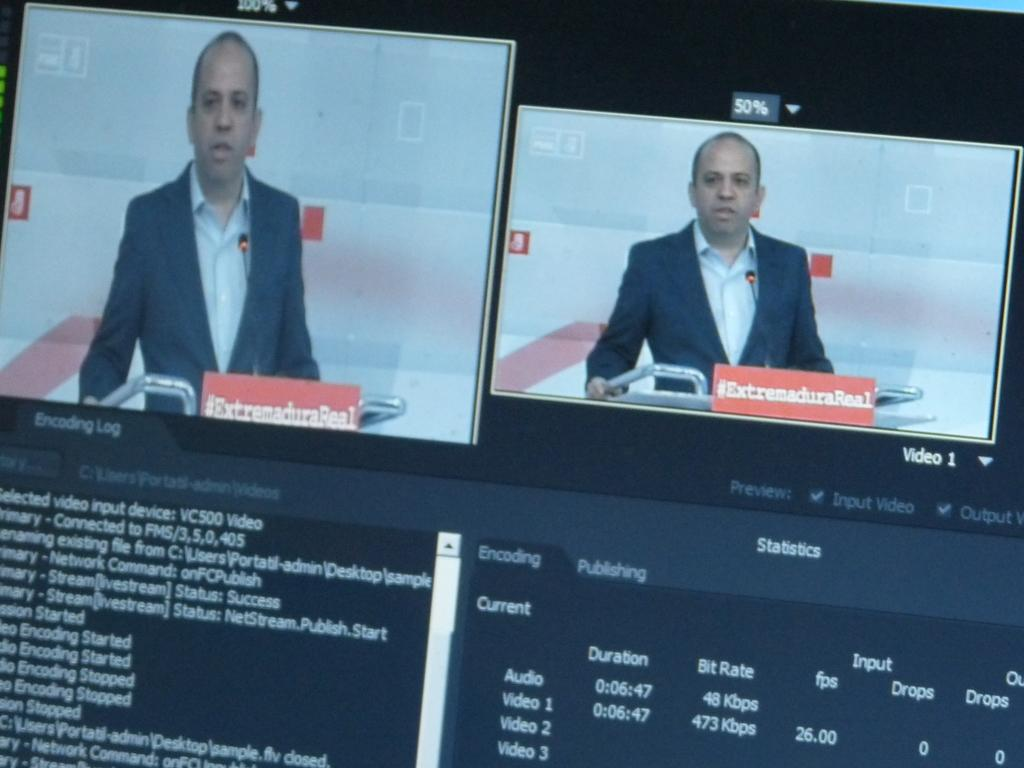How many televisions can be seen in the image? There are two televisions in the image. What else is present in the image besides the televisions? There is a person standing in the image. Can you see any waves in the image? There are no waves present in the image. What type of eggs are being used in the image? There are no eggs present in the image. 